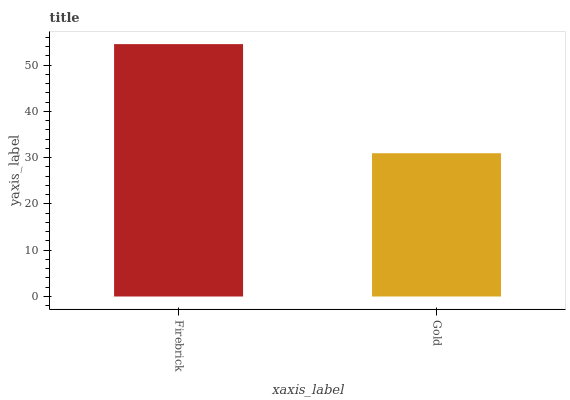Is Gold the minimum?
Answer yes or no. Yes. Is Firebrick the maximum?
Answer yes or no. Yes. Is Gold the maximum?
Answer yes or no. No. Is Firebrick greater than Gold?
Answer yes or no. Yes. Is Gold less than Firebrick?
Answer yes or no. Yes. Is Gold greater than Firebrick?
Answer yes or no. No. Is Firebrick less than Gold?
Answer yes or no. No. Is Firebrick the high median?
Answer yes or no. Yes. Is Gold the low median?
Answer yes or no. Yes. Is Gold the high median?
Answer yes or no. No. Is Firebrick the low median?
Answer yes or no. No. 